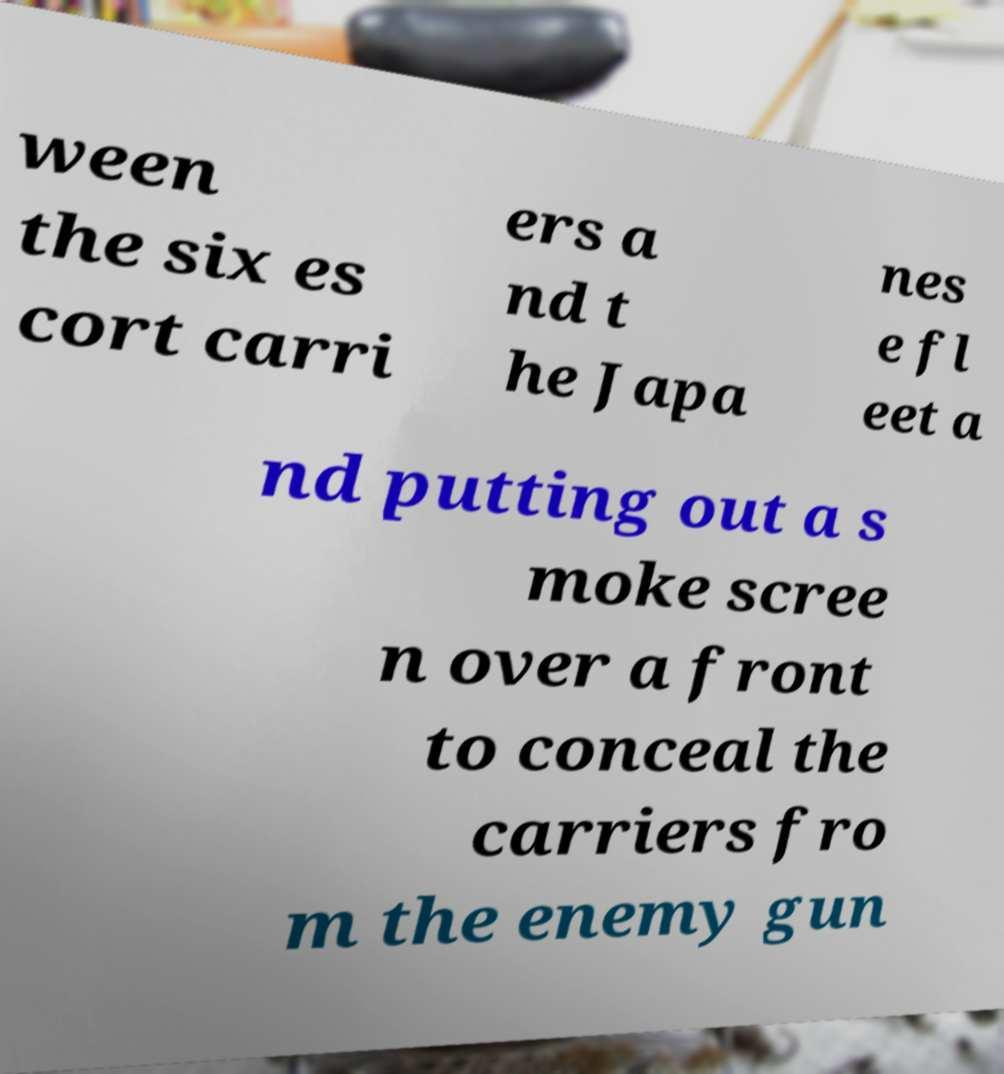There's text embedded in this image that I need extracted. Can you transcribe it verbatim? ween the six es cort carri ers a nd t he Japa nes e fl eet a nd putting out a s moke scree n over a front to conceal the carriers fro m the enemy gun 